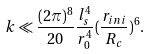<formula> <loc_0><loc_0><loc_500><loc_500>k \ll \frac { ( 2 \pi ) ^ { 8 } } { 2 0 } \frac { l _ { s } ^ { 4 } } { r _ { 0 } ^ { 4 } } ( \frac { r _ { i n i } } { R _ { c } } ) ^ { 6 } .</formula> 